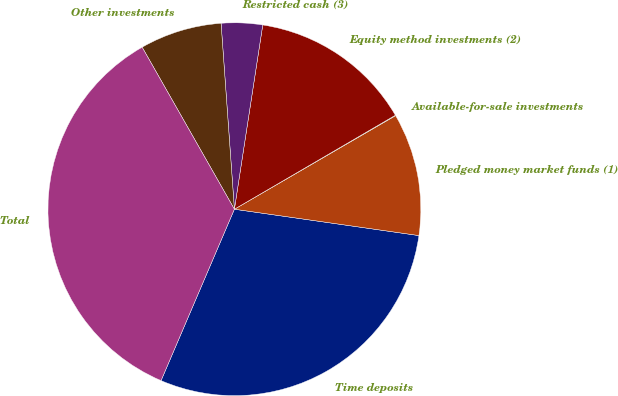Convert chart to OTSL. <chart><loc_0><loc_0><loc_500><loc_500><pie_chart><fcel>Time deposits<fcel>Pledged money market funds (1)<fcel>Available-for-sale investments<fcel>Equity method investments (2)<fcel>Restricted cash (3)<fcel>Other investments<fcel>Total<nl><fcel>29.18%<fcel>10.63%<fcel>0.04%<fcel>14.16%<fcel>3.57%<fcel>7.1%<fcel>35.33%<nl></chart> 